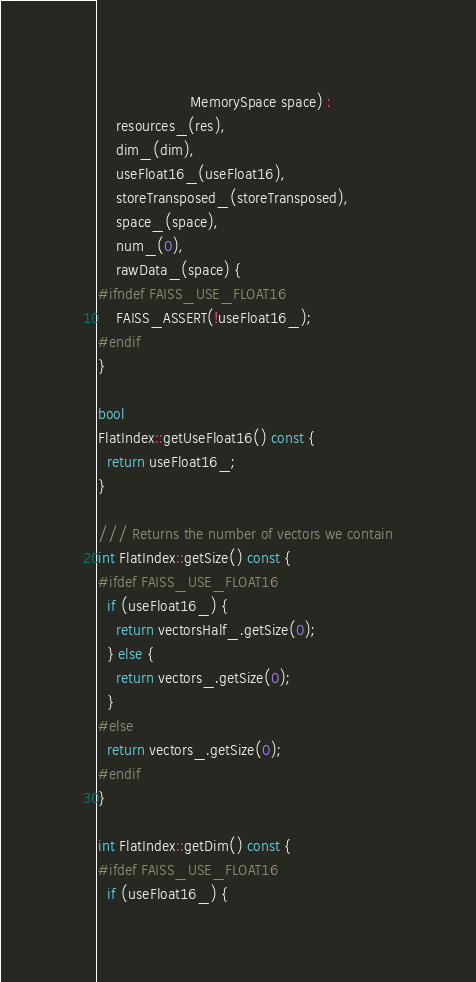Convert code to text. <code><loc_0><loc_0><loc_500><loc_500><_Cuda_>                     MemorySpace space) :
    resources_(res),
    dim_(dim),
    useFloat16_(useFloat16),
    storeTransposed_(storeTransposed),
    space_(space),
    num_(0),
    rawData_(space) {
#ifndef FAISS_USE_FLOAT16
    FAISS_ASSERT(!useFloat16_);
#endif
}

bool
FlatIndex::getUseFloat16() const {
  return useFloat16_;
}

/// Returns the number of vectors we contain
int FlatIndex::getSize() const {
#ifdef FAISS_USE_FLOAT16
  if (useFloat16_) {
    return vectorsHalf_.getSize(0);
  } else {
    return vectors_.getSize(0);
  }
#else
  return vectors_.getSize(0);
#endif
}

int FlatIndex::getDim() const {
#ifdef FAISS_USE_FLOAT16
  if (useFloat16_) {</code> 